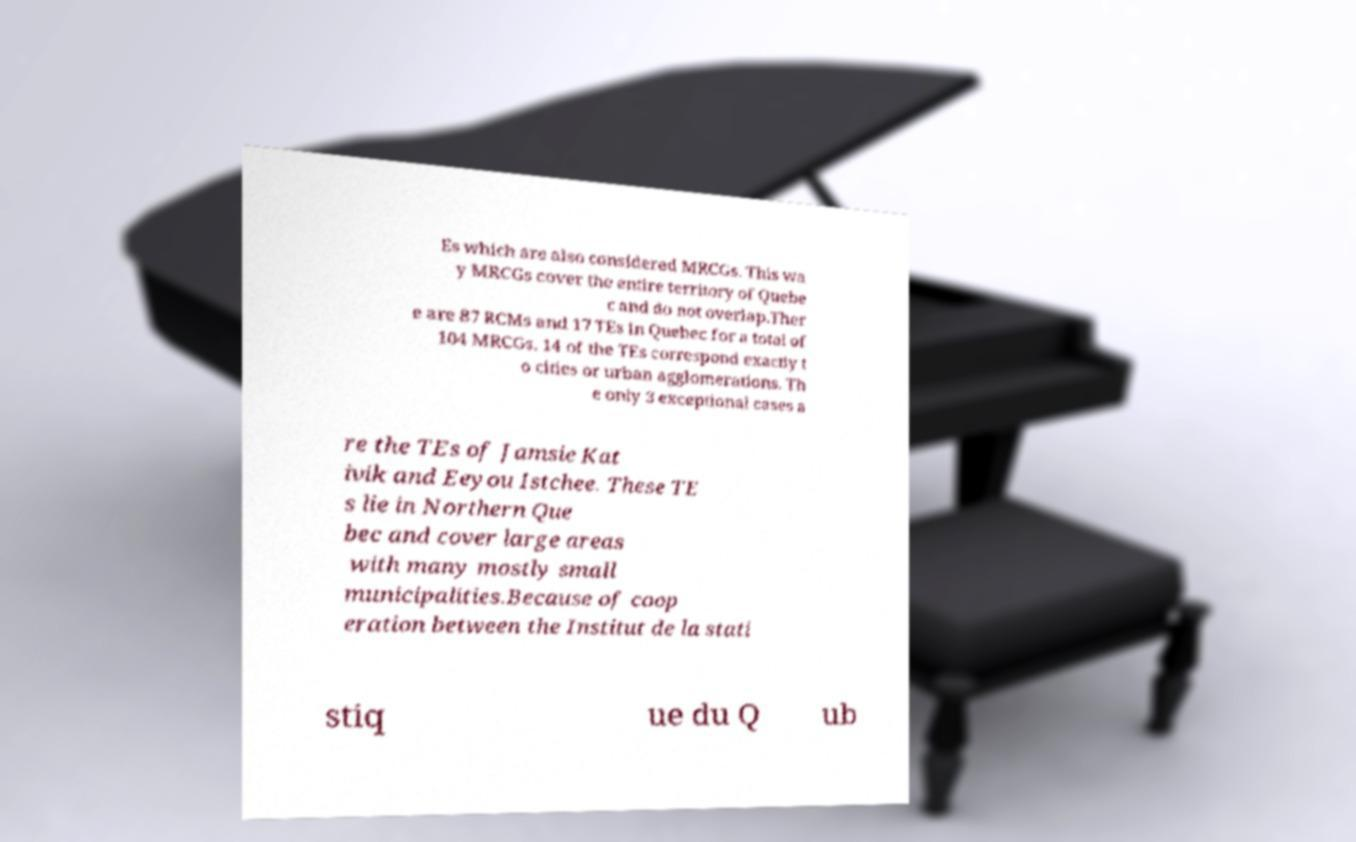There's text embedded in this image that I need extracted. Can you transcribe it verbatim? Es which are also considered MRCGs. This wa y MRCGs cover the entire territory of Quebe c and do not overlap.Ther e are 87 RCMs and 17 TEs in Quebec for a total of 104 MRCGs. 14 of the TEs correspond exactly t o cities or urban agglomerations. Th e only 3 exceptional cases a re the TEs of Jamsie Kat ivik and Eeyou Istchee. These TE s lie in Northern Que bec and cover large areas with many mostly small municipalities.Because of coop eration between the Institut de la stati stiq ue du Q ub 